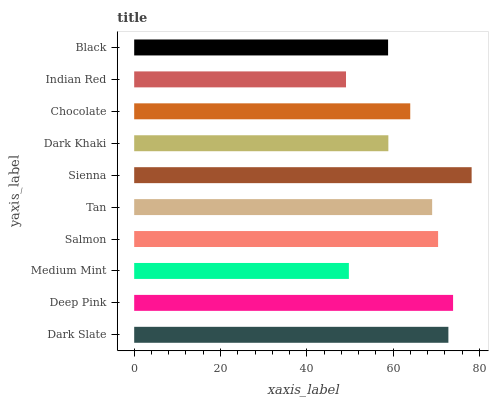Is Indian Red the minimum?
Answer yes or no. Yes. Is Sienna the maximum?
Answer yes or no. Yes. Is Deep Pink the minimum?
Answer yes or no. No. Is Deep Pink the maximum?
Answer yes or no. No. Is Deep Pink greater than Dark Slate?
Answer yes or no. Yes. Is Dark Slate less than Deep Pink?
Answer yes or no. Yes. Is Dark Slate greater than Deep Pink?
Answer yes or no. No. Is Deep Pink less than Dark Slate?
Answer yes or no. No. Is Tan the high median?
Answer yes or no. Yes. Is Chocolate the low median?
Answer yes or no. Yes. Is Sienna the high median?
Answer yes or no. No. Is Salmon the low median?
Answer yes or no. No. 